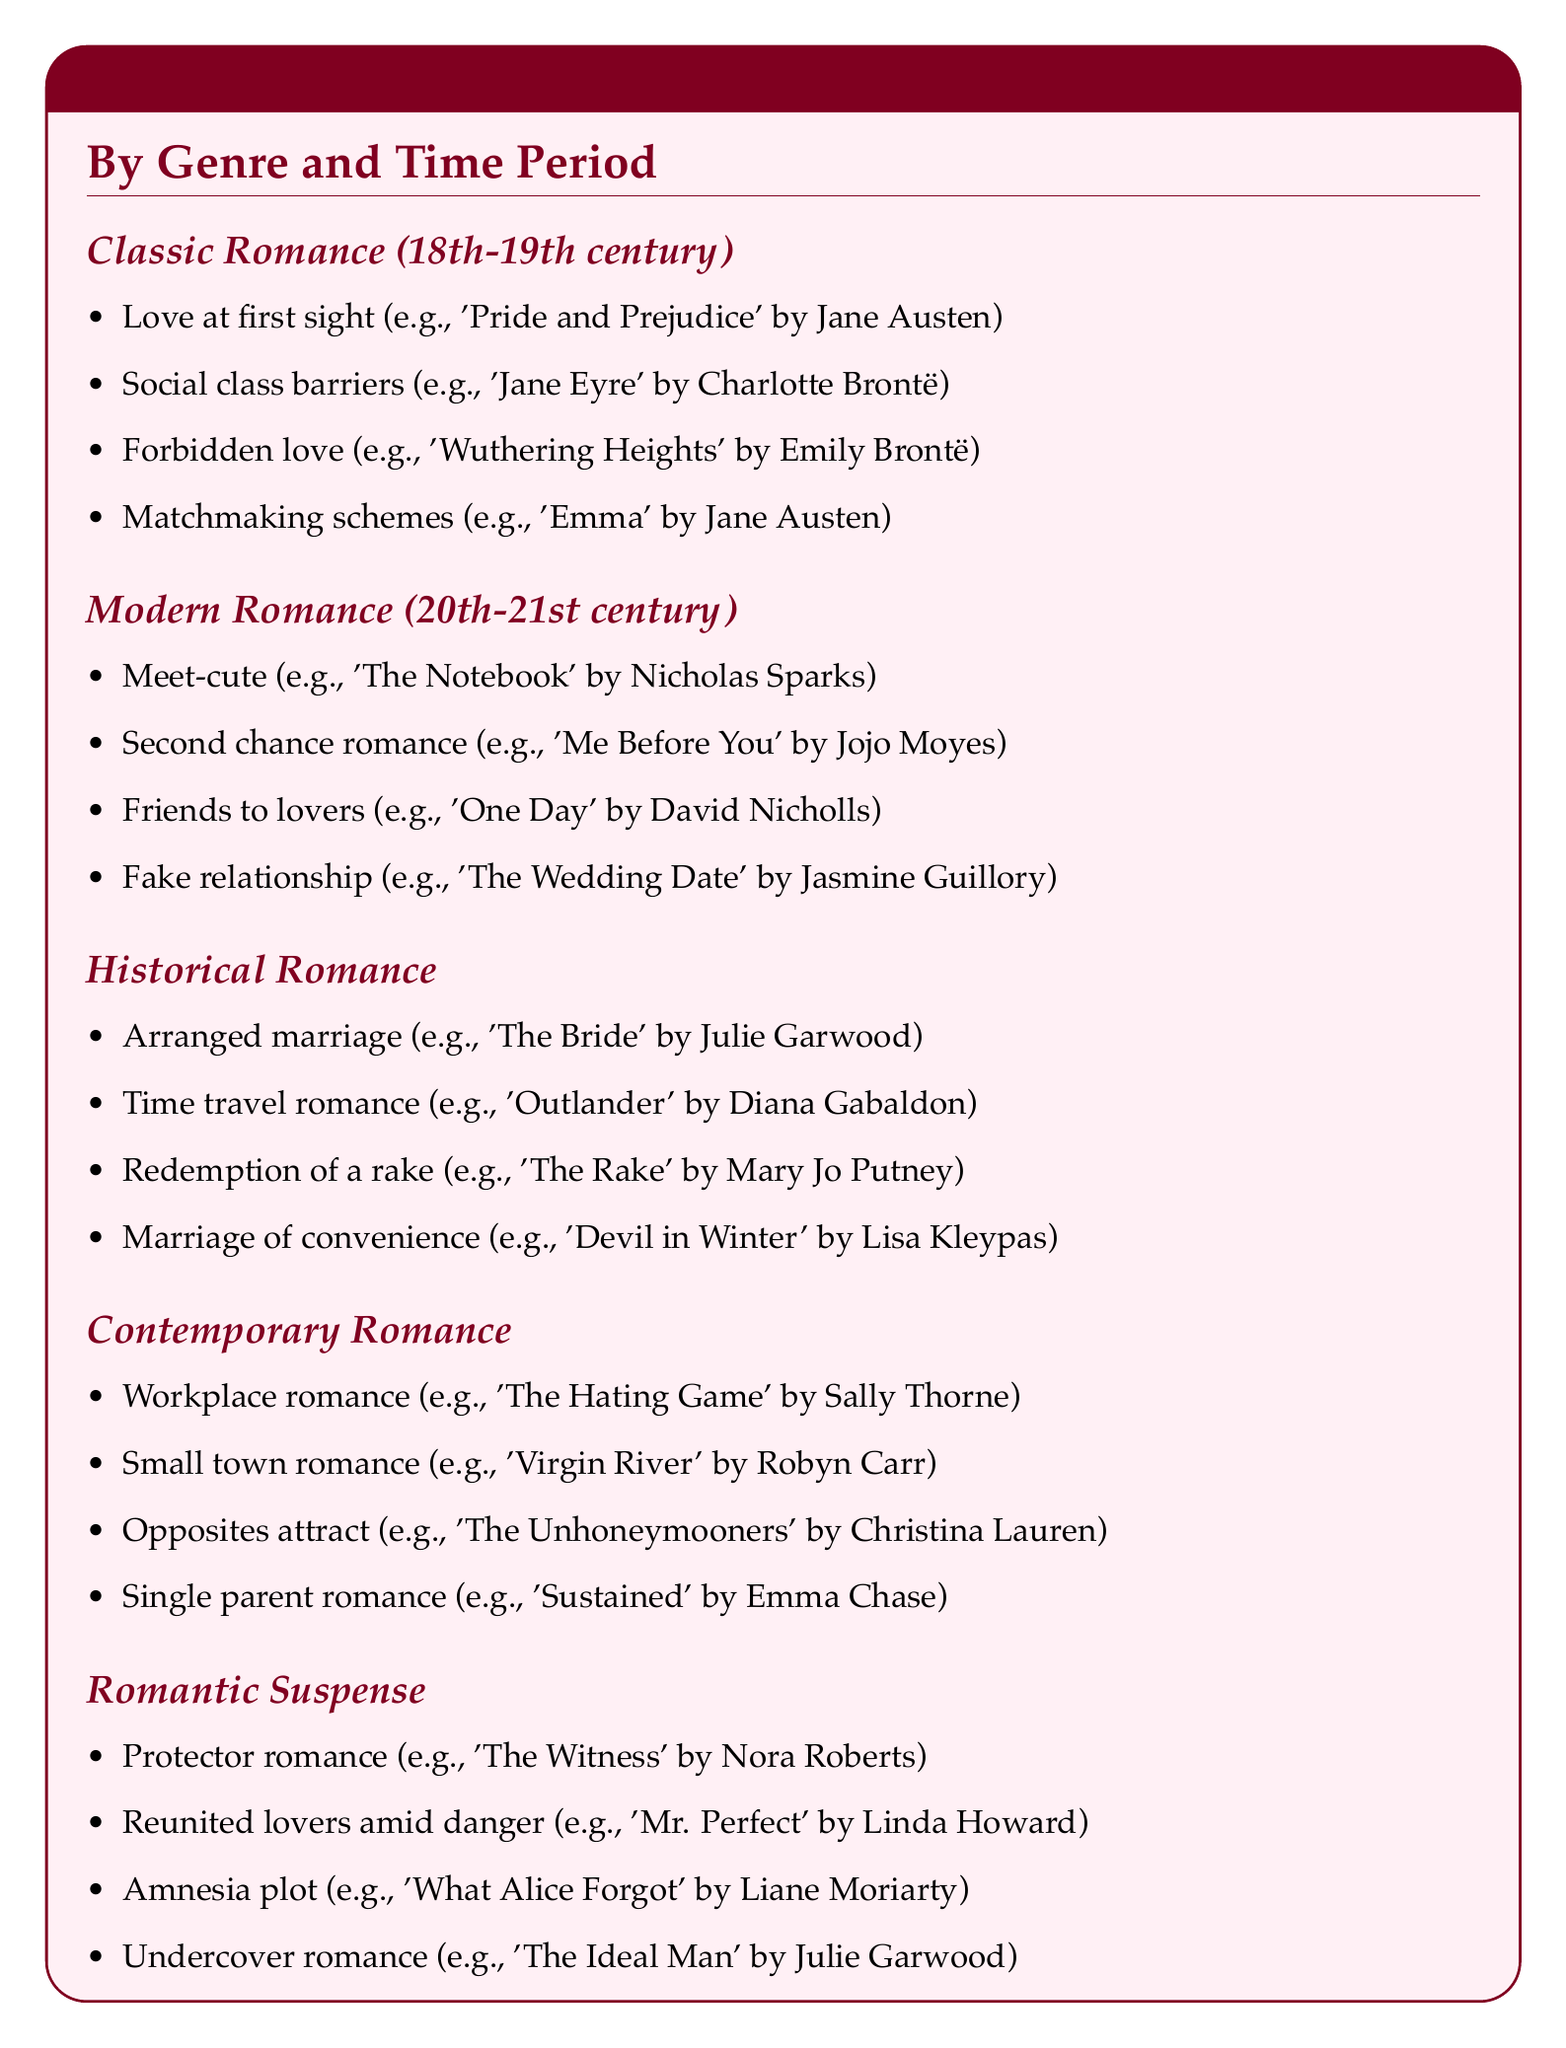What is an example of a matchmaking scheme? The document provides an example of matchmaking schemes from 'Emma' by Jane Austen.
Answer: 'Emma' by Jane Austen Which type of romance includes a meet-cute? The document states that a meet-cute is common in modern romance literature, exemplified by 'The Notebook' by Nicholas Sparks.
Answer: Modern Romance Name a book that features opposites attract. The document lists 'The Unhoneymooners' by Christina Lauren under the contemporary romance category as an example of opposites attract.
Answer: 'The Unhoneymooners' by Christina Lauren What is a common plot device in historical romance related to marriage? The document lists arranged marriage as a common plot device in historical romance.
Answer: Arranged marriage Which trope involves reunited lovers amid danger? 'Mr. Perfect' by Linda Howard is given as an example of reunited lovers amid danger in the romantic suspense section.
Answer: 'Mr. Perfect' by Linda Howard How many tropes are listed under contemporary romance? The document lists four tropes under contemporary romance, such as workplace romance and single parent romance.
Answer: Four What is a common theme found in classic romance literature? Social class barriers are mentioned as a common theme in classic romance literature, with 'Jane Eyre' by Charlotte Brontë as an example.
Answer: Social class barriers What type of romance does 'Outlander' represent? The document identifies 'Outlander' by Diana Gabaldon as a time travel romance, which fits within the historical romance category.
Answer: Historical Romance Which author wrote about a fake relationship in modern romance? 'The Wedding Date' by Jasmine Guillory is specified as a story featuring a fake relationship in modern romance.
Answer: Jasmine Guillory 